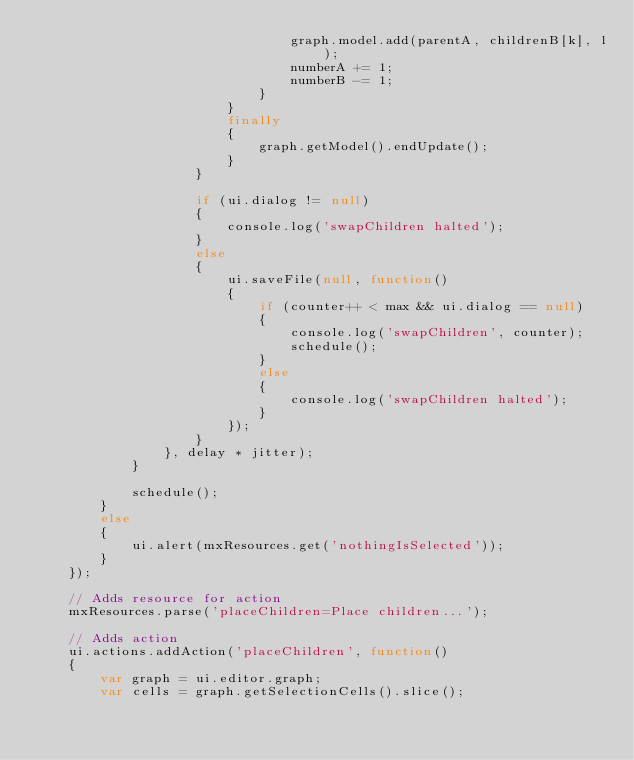Convert code to text. <code><loc_0><loc_0><loc_500><loc_500><_JavaScript_>								graph.model.add(parentA, childrenB[k], l);
								numberA += 1;
								numberB -= 1;
							}
						}
						finally
						{
							graph.getModel().endUpdate();
						}
					}
					
					if (ui.dialog != null)
					{
						console.log('swapChildren halted');
					}
					else
					{
						ui.saveFile(null, function()
						{
							if (counter++ < max && ui.dialog == null)
							{
								console.log('swapChildren', counter);
								schedule();
							}
							else
							{
								console.log('swapChildren halted');
							}
						});
					}
				}, delay * jitter);
			}
			
			schedule();
		}
		else
		{
			ui.alert(mxResources.get('nothingIsSelected'));
		}
	});
	
	// Adds resource for action
	mxResources.parse('placeChildren=Place children...');

	// Adds action
	ui.actions.addAction('placeChildren', function()
	{
		var graph = ui.editor.graph;
		var cells = graph.getSelectionCells().slice();
		</code> 